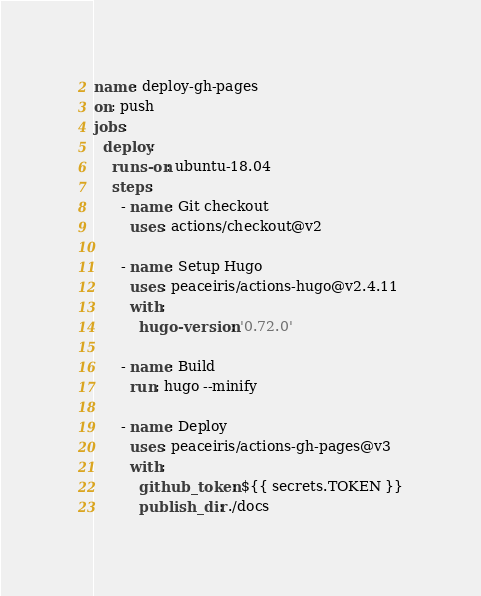Convert code to text. <code><loc_0><loc_0><loc_500><loc_500><_YAML_>name: deploy-gh-pages
on: push
jobs:
  deploy:
    runs-on: ubuntu-18.04
    steps:
      - name: Git checkout
        uses: actions/checkout@v2

      - name: Setup Hugo
        uses: peaceiris/actions-hugo@v2.4.11
        with:
          hugo-version: '0.72.0'

      - name: Build
        run: hugo --minify

      - name: Deploy
        uses: peaceiris/actions-gh-pages@v3
        with:
          github_token: ${{ secrets.TOKEN }}
          publish_dir: ./docs
</code> 